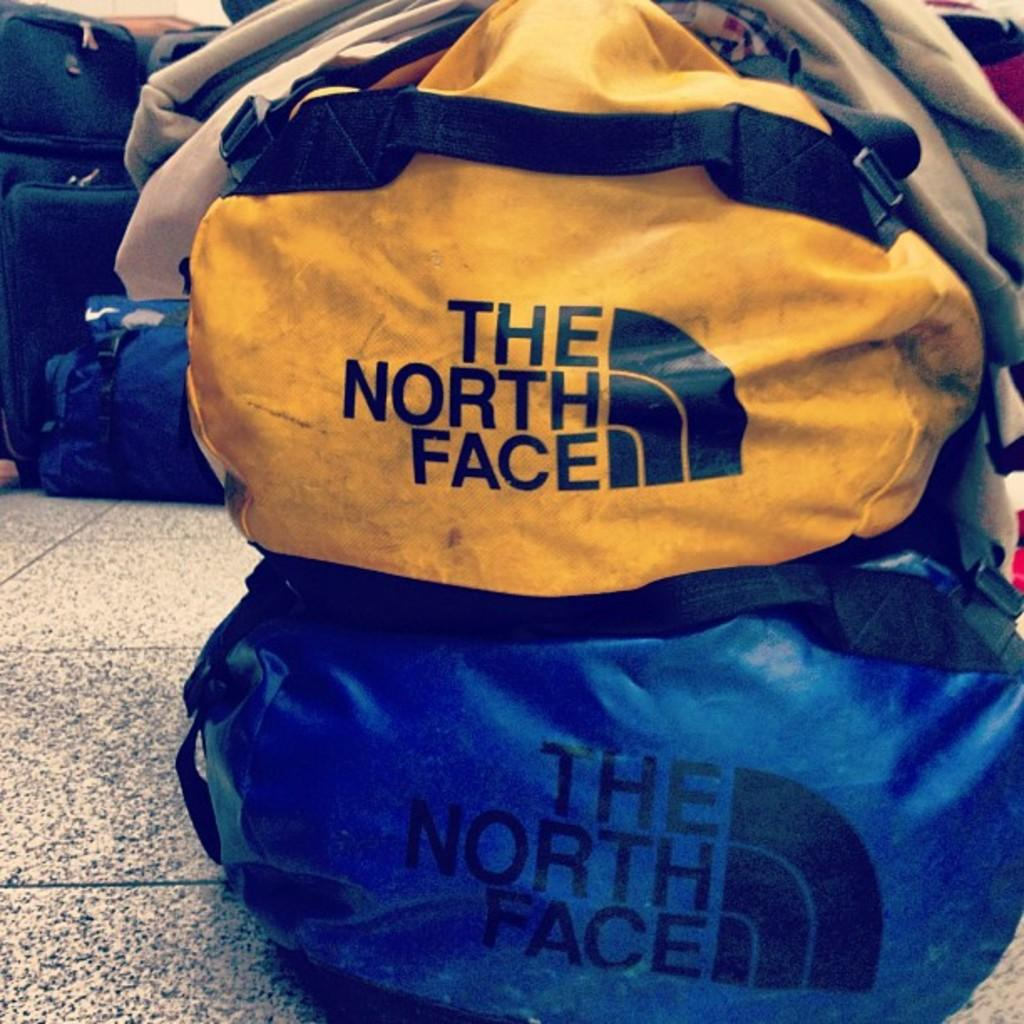What objects are present in the image? There are bags in the image. What type of fruit is being discussed by the government in the image? There is no fruit or government present in the image; it only features bags. What is the expansion plan for the bags in the image? There is no expansion plan mentioned in the image, as it only shows bags without any additional context or information. 